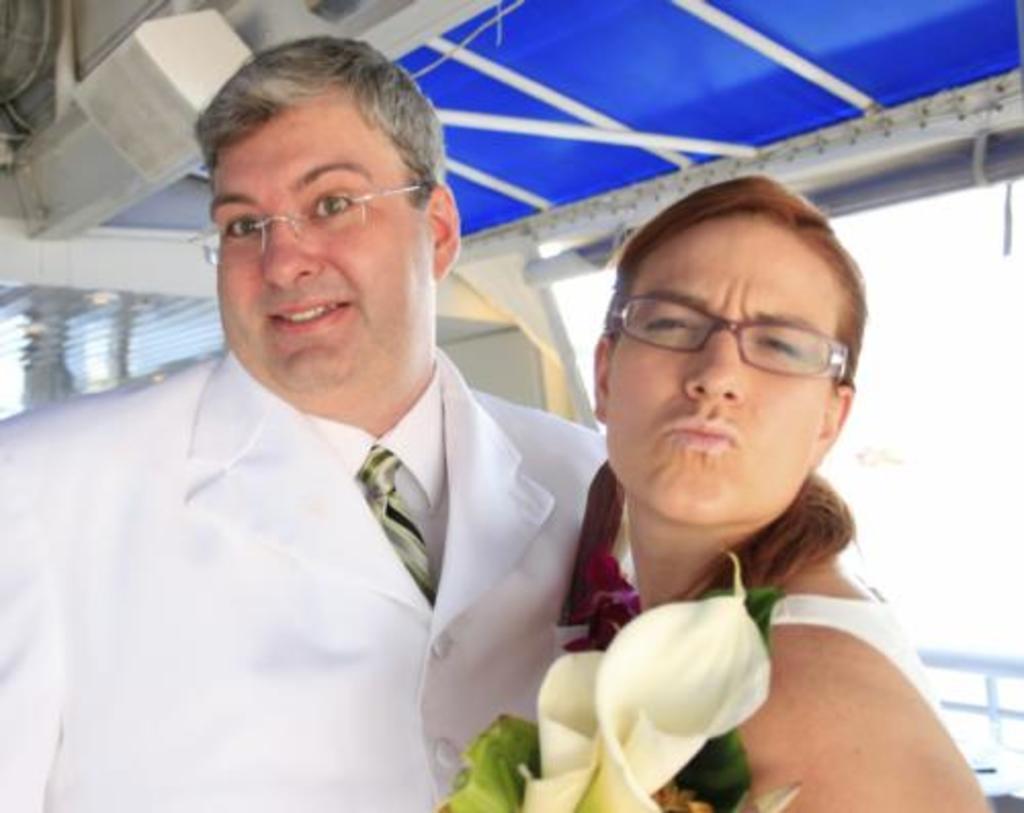Can you describe this image briefly? In this picture there are two persons standing and the woman is holding the flowers. At the back there is a window. At the top there is a pipe. In the bottom right there is a railing. 